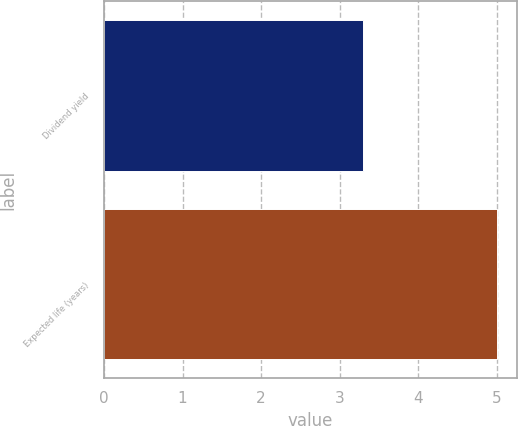Convert chart to OTSL. <chart><loc_0><loc_0><loc_500><loc_500><bar_chart><fcel>Dividend yield<fcel>Expected life (years)<nl><fcel>3.3<fcel>5<nl></chart> 